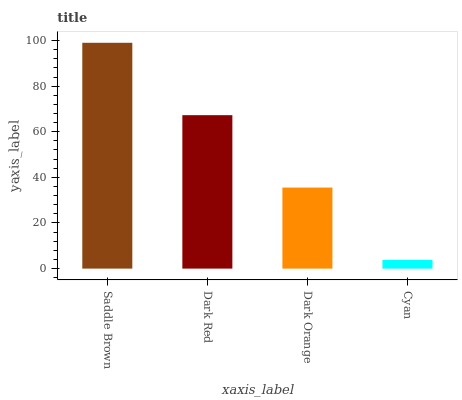Is Cyan the minimum?
Answer yes or no. Yes. Is Saddle Brown the maximum?
Answer yes or no. Yes. Is Dark Red the minimum?
Answer yes or no. No. Is Dark Red the maximum?
Answer yes or no. No. Is Saddle Brown greater than Dark Red?
Answer yes or no. Yes. Is Dark Red less than Saddle Brown?
Answer yes or no. Yes. Is Dark Red greater than Saddle Brown?
Answer yes or no. No. Is Saddle Brown less than Dark Red?
Answer yes or no. No. Is Dark Red the high median?
Answer yes or no. Yes. Is Dark Orange the low median?
Answer yes or no. Yes. Is Dark Orange the high median?
Answer yes or no. No. Is Saddle Brown the low median?
Answer yes or no. No. 